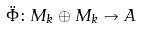<formula> <loc_0><loc_0><loc_500><loc_500>\ddot { \Phi } \colon M _ { k } \oplus M _ { k } \to A</formula> 